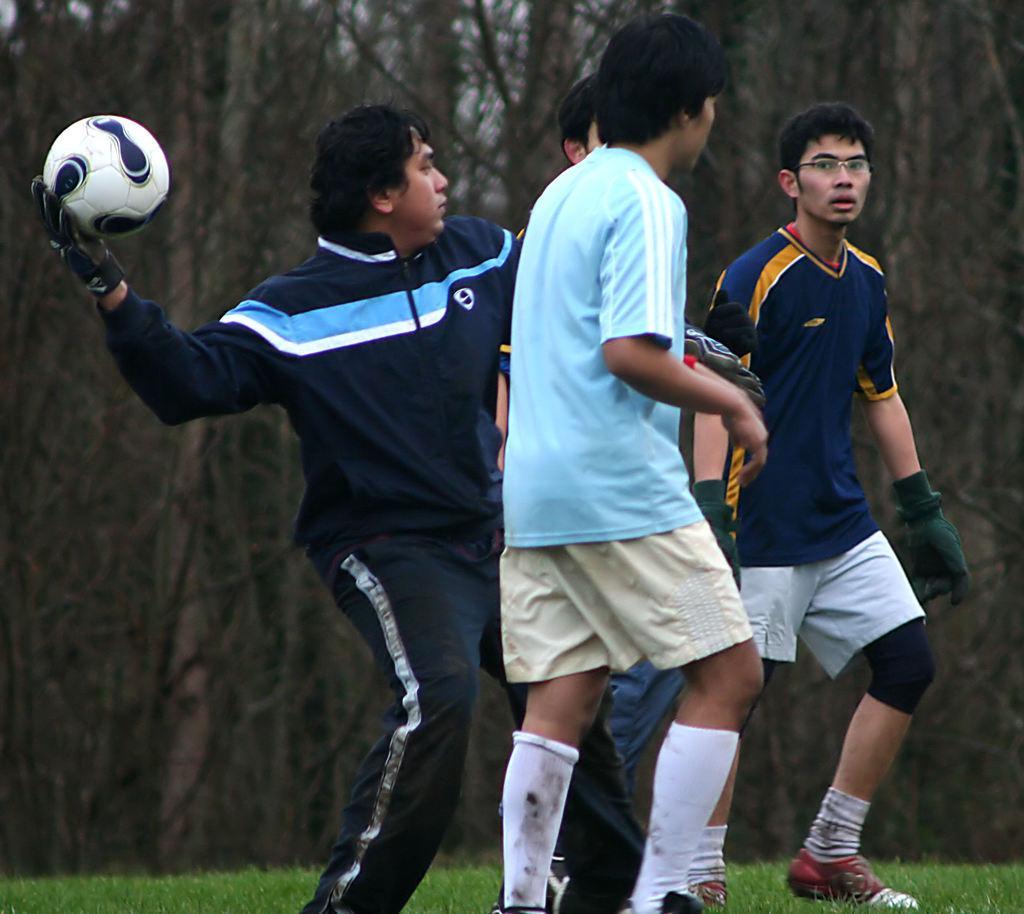Can you describe this image briefly? There are four people. They are standing. On the left side we have a person. He's holding a ball. We can see in background trees. 